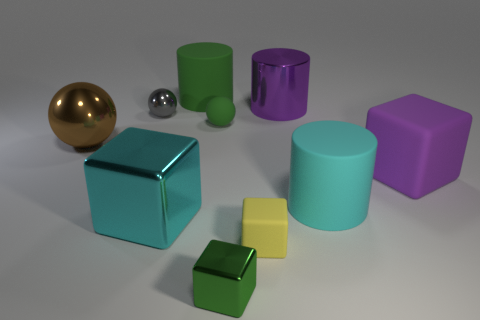Is the big green cylinder made of the same material as the large sphere?
Offer a very short reply. No. What number of shiny objects are small gray spheres or cylinders?
Make the answer very short. 2. There is a big rubber object that is the same color as the metallic cylinder; what is its shape?
Ensure brevity in your answer.  Cube. Does the rubber cube on the left side of the cyan rubber thing have the same color as the big metal cylinder?
Give a very brief answer. No. There is a large cyan thing that is on the left side of the green cylinder that is on the left side of the large purple cube; what shape is it?
Your answer should be very brief. Cube. What number of objects are shiny balls behind the brown metal ball or cylinders that are to the left of the big cyan cylinder?
Provide a succinct answer. 3. There is a tiny gray object that is the same material as the brown thing; what is its shape?
Give a very brief answer. Sphere. Are there any other things that are the same color as the tiny rubber block?
Offer a terse response. No. What material is the green object that is the same shape as the large brown metal object?
Keep it short and to the point. Rubber. What number of other objects are the same size as the cyan metal cube?
Provide a short and direct response. 5. 